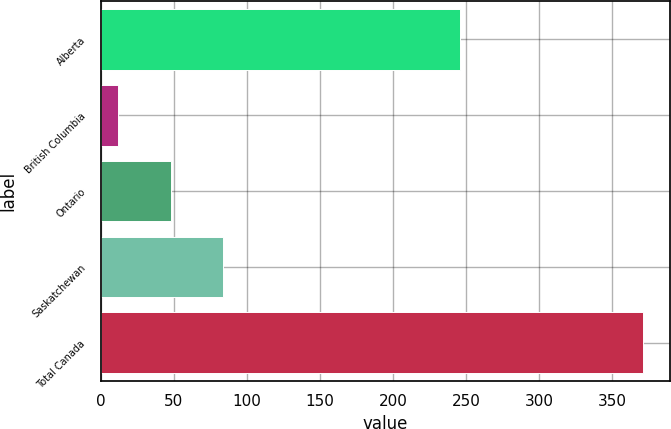Convert chart to OTSL. <chart><loc_0><loc_0><loc_500><loc_500><bar_chart><fcel>Alberta<fcel>British Columbia<fcel>Ontario<fcel>Saskatchewan<fcel>Total Canada<nl><fcel>246<fcel>12<fcel>47.9<fcel>83.8<fcel>371<nl></chart> 